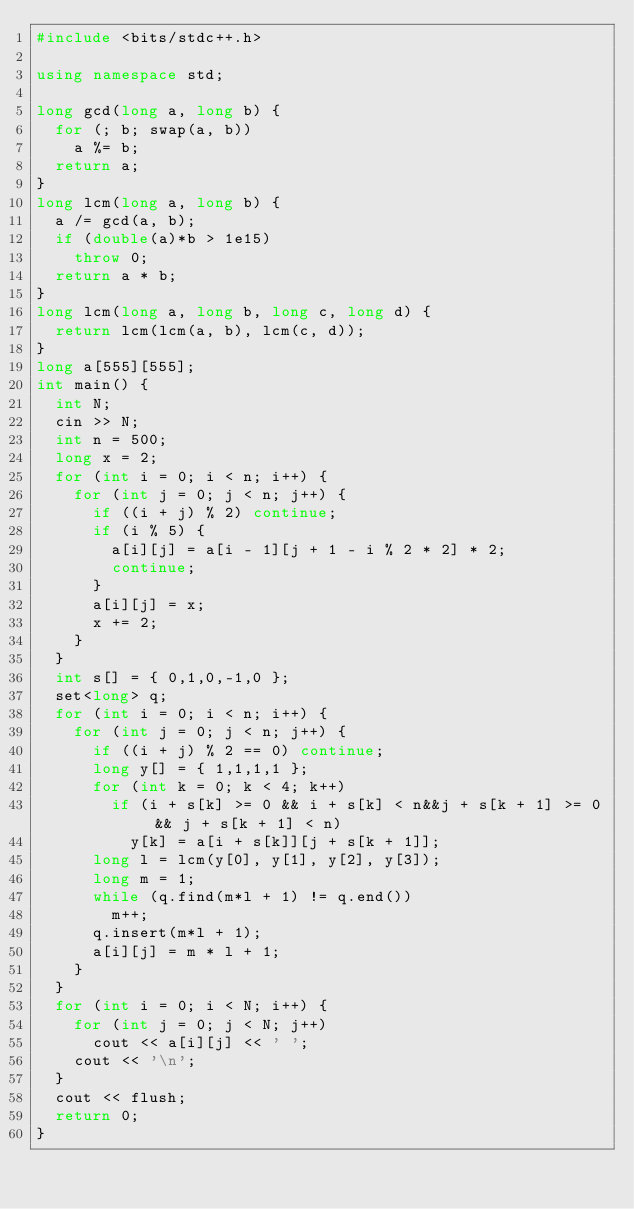<code> <loc_0><loc_0><loc_500><loc_500><_C++_>#include <bits/stdc++.h>

using namespace std;

long gcd(long a, long b) {
	for (; b; swap(a, b))
		a %= b;
	return a;
}
long lcm(long a, long b) {
	a /= gcd(a, b);
	if (double(a)*b > 1e15)
		throw 0;
	return a * b;
}
long lcm(long a, long b, long c, long d) {
	return lcm(lcm(a, b), lcm(c, d));
}
long a[555][555];
int main() {
	int N;
	cin >> N;
	int n = 500;
	long x = 2;
	for (int i = 0; i < n; i++) {
		for (int j = 0; j < n; j++) {
			if ((i + j) % 2) continue;
			if (i % 5) {
				a[i][j] = a[i - 1][j + 1 - i % 2 * 2] * 2;
				continue;
			}
			a[i][j] = x;
			x += 2;
		}
	}
	int s[] = { 0,1,0,-1,0 };
	set<long> q;
	for (int i = 0; i < n; i++) {
		for (int j = 0; j < n; j++) {
			if ((i + j) % 2 == 0) continue;
			long y[] = { 1,1,1,1 };
			for (int k = 0; k < 4; k++)
				if (i + s[k] >= 0 && i + s[k] < n&&j + s[k + 1] >= 0 && j + s[k + 1] < n)
					y[k] = a[i + s[k]][j + s[k + 1]];
			long l = lcm(y[0], y[1], y[2], y[3]);
			long m = 1;
			while (q.find(m*l + 1) != q.end())
				m++;
			q.insert(m*l + 1);
			a[i][j] = m * l + 1;
		}
	}
	for (int i = 0; i < N; i++) {
		for (int j = 0; j < N; j++)
			cout << a[i][j] << ' ';
		cout << '\n';
	}
	cout << flush;
	return 0;
}
</code> 